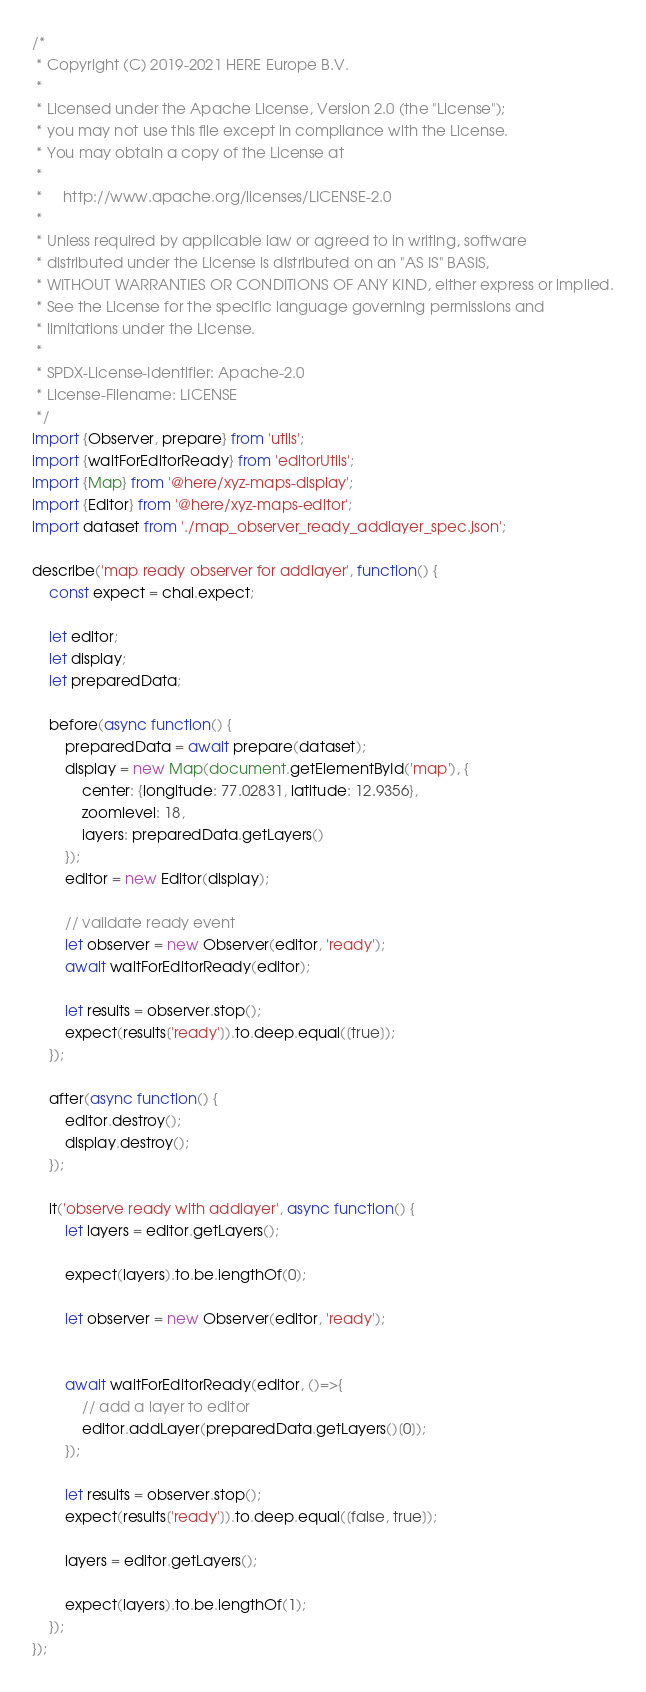Convert code to text. <code><loc_0><loc_0><loc_500><loc_500><_JavaScript_>/*
 * Copyright (C) 2019-2021 HERE Europe B.V.
 *
 * Licensed under the Apache License, Version 2.0 (the "License");
 * you may not use this file except in compliance with the License.
 * You may obtain a copy of the License at
 *
 *     http://www.apache.org/licenses/LICENSE-2.0
 *
 * Unless required by applicable law or agreed to in writing, software
 * distributed under the License is distributed on an "AS IS" BASIS,
 * WITHOUT WARRANTIES OR CONDITIONS OF ANY KIND, either express or implied.
 * See the License for the specific language governing permissions and
 * limitations under the License.
 *
 * SPDX-License-Identifier: Apache-2.0
 * License-Filename: LICENSE
 */
import {Observer, prepare} from 'utils';
import {waitForEditorReady} from 'editorUtils';
import {Map} from '@here/xyz-maps-display';
import {Editor} from '@here/xyz-maps-editor';
import dataset from './map_observer_ready_addlayer_spec.json';

describe('map ready observer for addlayer', function() {
    const expect = chai.expect;

    let editor;
    let display;
    let preparedData;

    before(async function() {
        preparedData = await prepare(dataset);
        display = new Map(document.getElementById('map'), {
            center: {longitude: 77.02831, latitude: 12.9356},
            zoomlevel: 18,
            layers: preparedData.getLayers()
        });
        editor = new Editor(display);

        // validate ready event
        let observer = new Observer(editor, 'ready');
        await waitForEditorReady(editor);

        let results = observer.stop();
        expect(results['ready']).to.deep.equal([true]);
    });

    after(async function() {
        editor.destroy();
        display.destroy();
    });

    it('observe ready with addlayer', async function() {
        let layers = editor.getLayers();

        expect(layers).to.be.lengthOf(0);

        let observer = new Observer(editor, 'ready');


        await waitForEditorReady(editor, ()=>{
            // add a layer to editor
            editor.addLayer(preparedData.getLayers()[0]);
        });

        let results = observer.stop();
        expect(results['ready']).to.deep.equal([false, true]);

        layers = editor.getLayers();

        expect(layers).to.be.lengthOf(1);
    });
});
</code> 